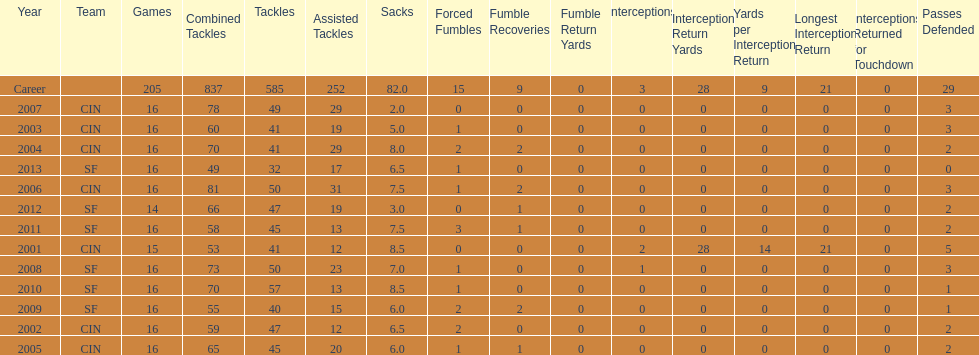Parse the full table. {'header': ['Year', 'Team', 'Games', 'Combined Tackles', 'Tackles', 'Assisted Tackles', 'Sacks', 'Forced Fumbles', 'Fumble Recoveries', 'Fumble Return Yards', 'Interceptions', 'Interception Return Yards', 'Yards per Interception Return', 'Longest Interception Return', 'Interceptions Returned for Touchdown', 'Passes Defended'], 'rows': [['Career', '', '205', '837', '585', '252', '82.0', '15', '9', '0', '3', '28', '9', '21', '0', '29'], ['2007', 'CIN', '16', '78', '49', '29', '2.0', '0', '0', '0', '0', '0', '0', '0', '0', '3'], ['2003', 'CIN', '16', '60', '41', '19', '5.0', '1', '0', '0', '0', '0', '0', '0', '0', '3'], ['2004', 'CIN', '16', '70', '41', '29', '8.0', '2', '2', '0', '0', '0', '0', '0', '0', '2'], ['2013', 'SF', '16', '49', '32', '17', '6.5', '1', '0', '0', '0', '0', '0', '0', '0', '0'], ['2006', 'CIN', '16', '81', '50', '31', '7.5', '1', '2', '0', '0', '0', '0', '0', '0', '3'], ['2012', 'SF', '14', '66', '47', '19', '3.0', '0', '1', '0', '0', '0', '0', '0', '0', '2'], ['2011', 'SF', '16', '58', '45', '13', '7.5', '3', '1', '0', '0', '0', '0', '0', '0', '2'], ['2001', 'CIN', '15', '53', '41', '12', '8.5', '0', '0', '0', '2', '28', '14', '21', '0', '5'], ['2008', 'SF', '16', '73', '50', '23', '7.0', '1', '0', '0', '1', '0', '0', '0', '0', '3'], ['2010', 'SF', '16', '70', '57', '13', '8.5', '1', '0', '0', '0', '0', '0', '0', '0', '1'], ['2009', 'SF', '16', '55', '40', '15', '6.0', '2', '2', '0', '0', '0', '0', '0', '0', '1'], ['2002', 'CIN', '16', '59', '47', '12', '6.5', '2', '0', '0', '0', '0', '0', '0', '0', '2'], ['2005', 'CIN', '16', '65', '45', '20', '6.0', '1', '1', '0', '0', '0', '0', '0', '0', '2']]} What is the total number of sacks smith has made? 82.0. 